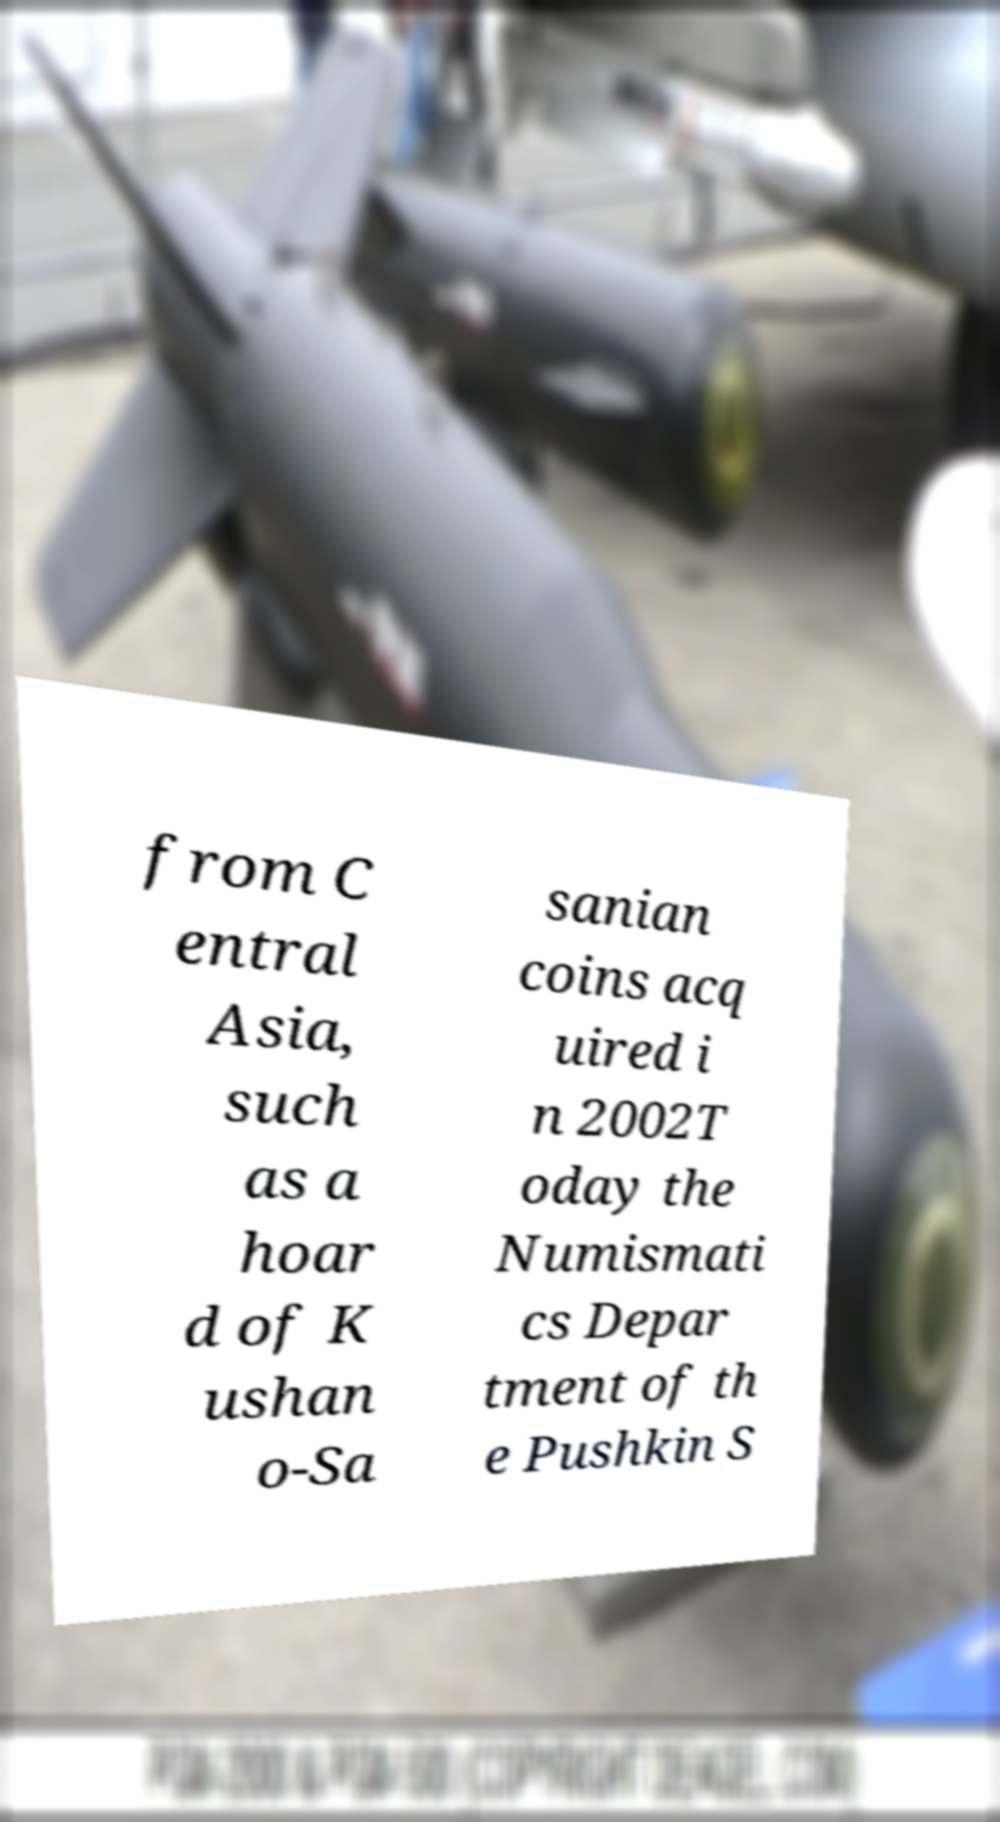Please read and relay the text visible in this image. What does it say? from C entral Asia, such as a hoar d of K ushan o-Sa sanian coins acq uired i n 2002T oday the Numismati cs Depar tment of th e Pushkin S 